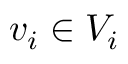Convert formula to latex. <formula><loc_0><loc_0><loc_500><loc_500>v _ { i } \in V _ { i }</formula> 